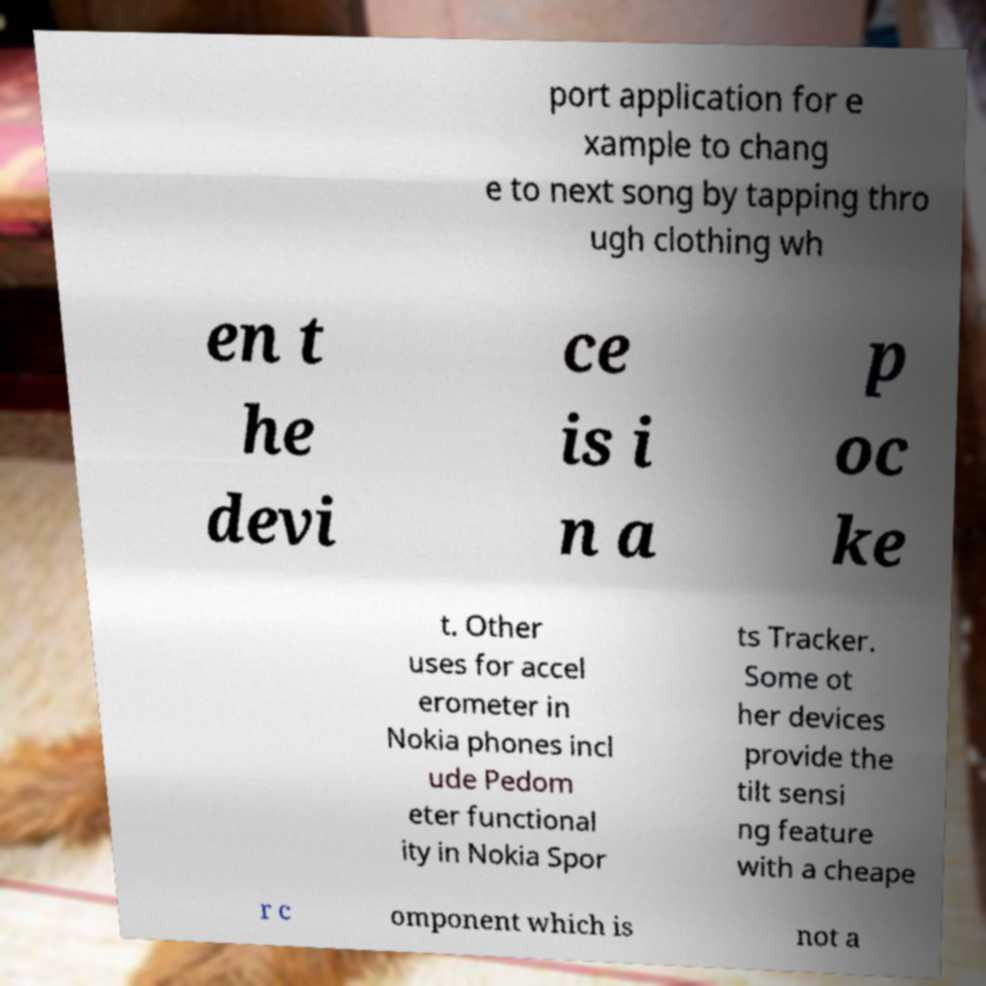What messages or text are displayed in this image? I need them in a readable, typed format. port application for e xample to chang e to next song by tapping thro ugh clothing wh en t he devi ce is i n a p oc ke t. Other uses for accel erometer in Nokia phones incl ude Pedom eter functional ity in Nokia Spor ts Tracker. Some ot her devices provide the tilt sensi ng feature with a cheape r c omponent which is not a 